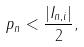<formula> <loc_0><loc_0><loc_500><loc_500>p _ { n } < \frac { | I _ { n , i } | } { 2 } ,</formula> 